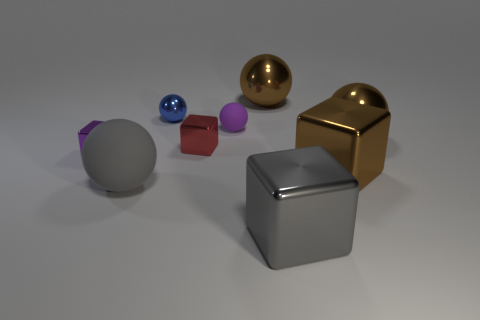Subtract 1 blocks. How many blocks are left? 3 Subtract all gray balls. How many balls are left? 4 Subtract all small purple spheres. How many spheres are left? 4 Subtract all cyan spheres. Subtract all yellow blocks. How many spheres are left? 5 Add 1 tiny blue metal cylinders. How many objects exist? 10 Subtract all cubes. How many objects are left? 5 Add 6 small matte objects. How many small matte objects are left? 7 Add 4 small purple metallic blocks. How many small purple metallic blocks exist? 5 Subtract 0 gray cylinders. How many objects are left? 9 Subtract all gray spheres. Subtract all big metallic spheres. How many objects are left? 6 